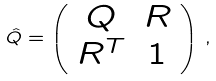Convert formula to latex. <formula><loc_0><loc_0><loc_500><loc_500>\hat { Q } = \left ( \begin{array} { c c } Q & R \\ R ^ { T } & 1 \end{array} \right ) \, ,</formula> 